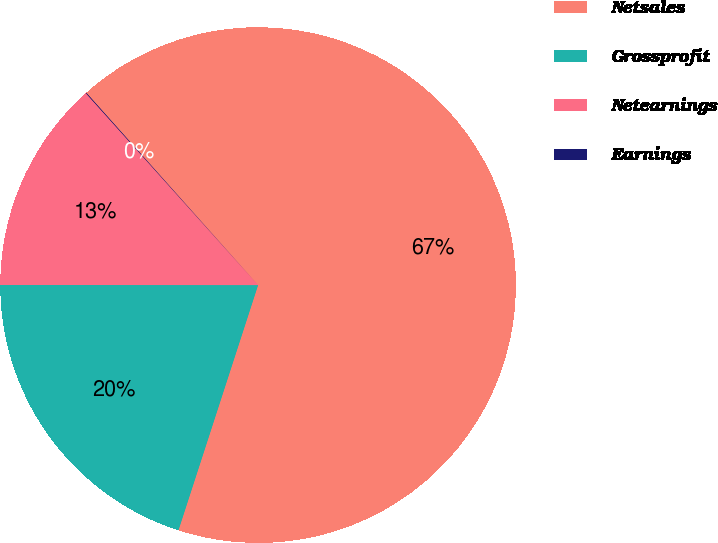<chart> <loc_0><loc_0><loc_500><loc_500><pie_chart><fcel>Netsales<fcel>Grossprofit<fcel>Netearnings<fcel>Earnings<nl><fcel>66.6%<fcel>20.01%<fcel>13.35%<fcel>0.04%<nl></chart> 